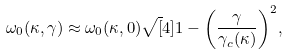<formula> <loc_0><loc_0><loc_500><loc_500>\omega _ { 0 } ( \kappa , \gamma ) \approx \omega _ { 0 } ( \kappa , 0 ) \sqrt { [ } 4 ] { 1 - \left ( \frac { \gamma } { \gamma _ { c } ( \kappa ) } \right ) ^ { 2 } } ,</formula> 